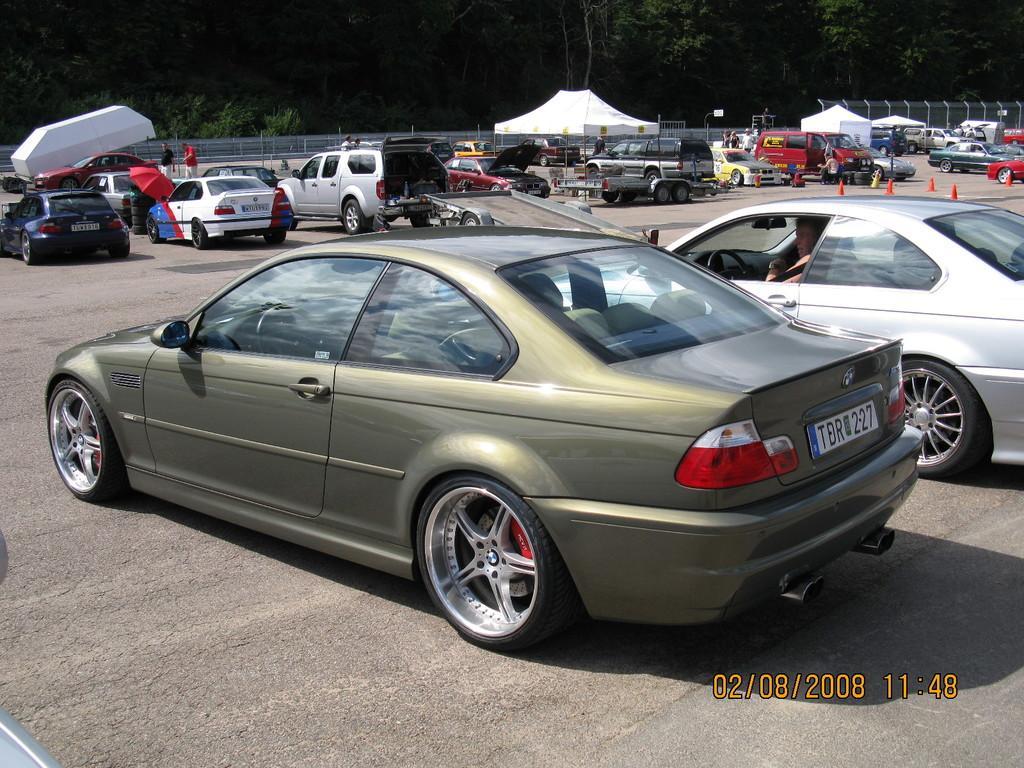Describe this image in one or two sentences. In this picture we can see some cars on the road. Here this is an umbrella. There is a fence and on the background there are trees. 